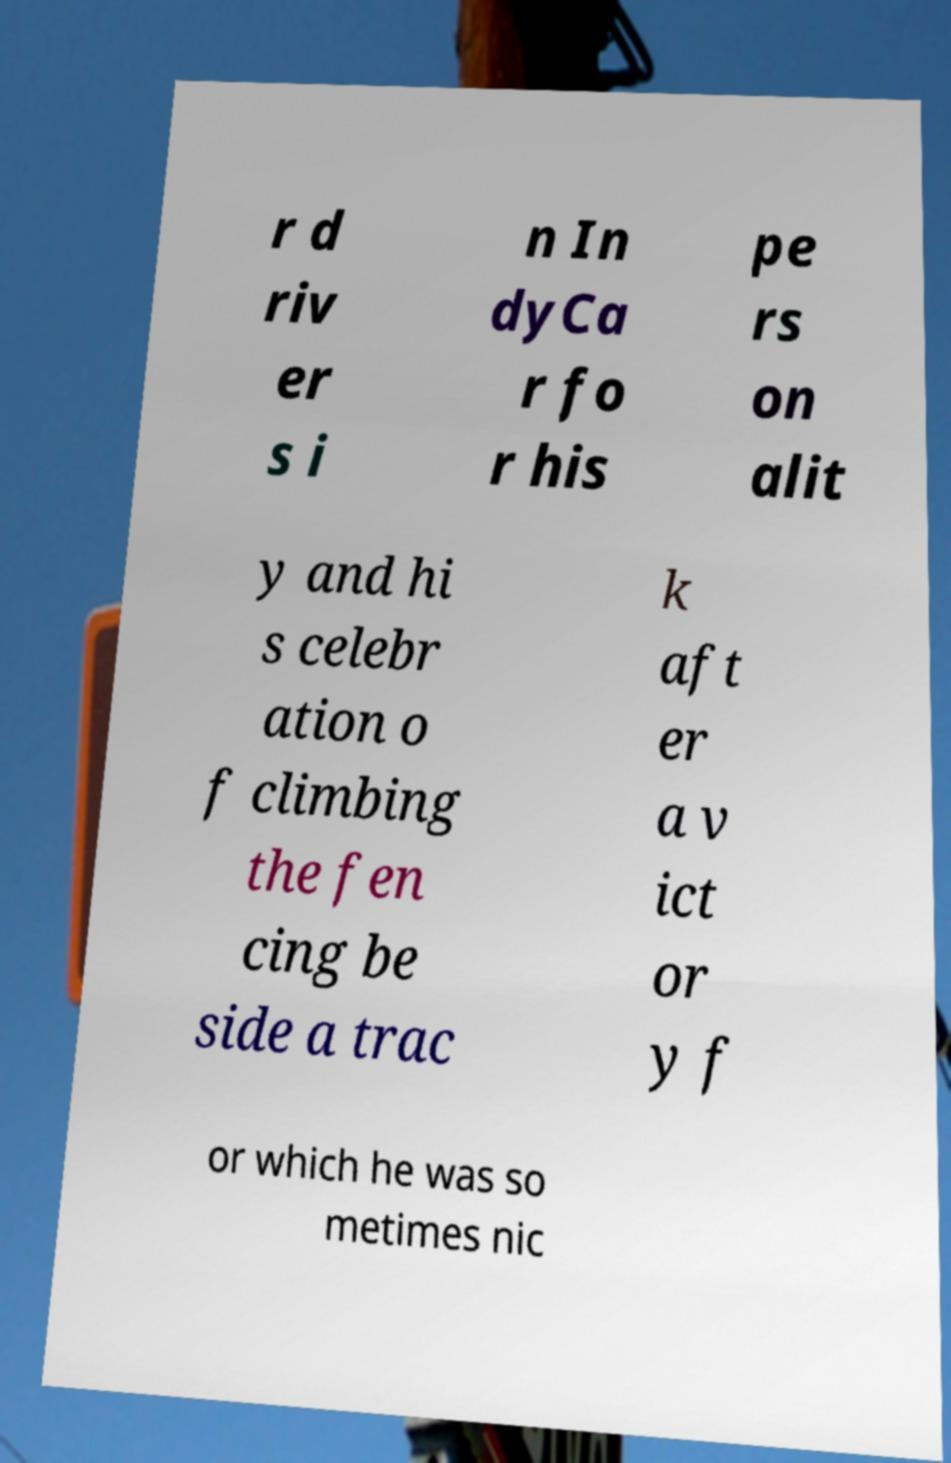What messages or text are displayed in this image? I need them in a readable, typed format. r d riv er s i n In dyCa r fo r his pe rs on alit y and hi s celebr ation o f climbing the fen cing be side a trac k aft er a v ict or y f or which he was so metimes nic 